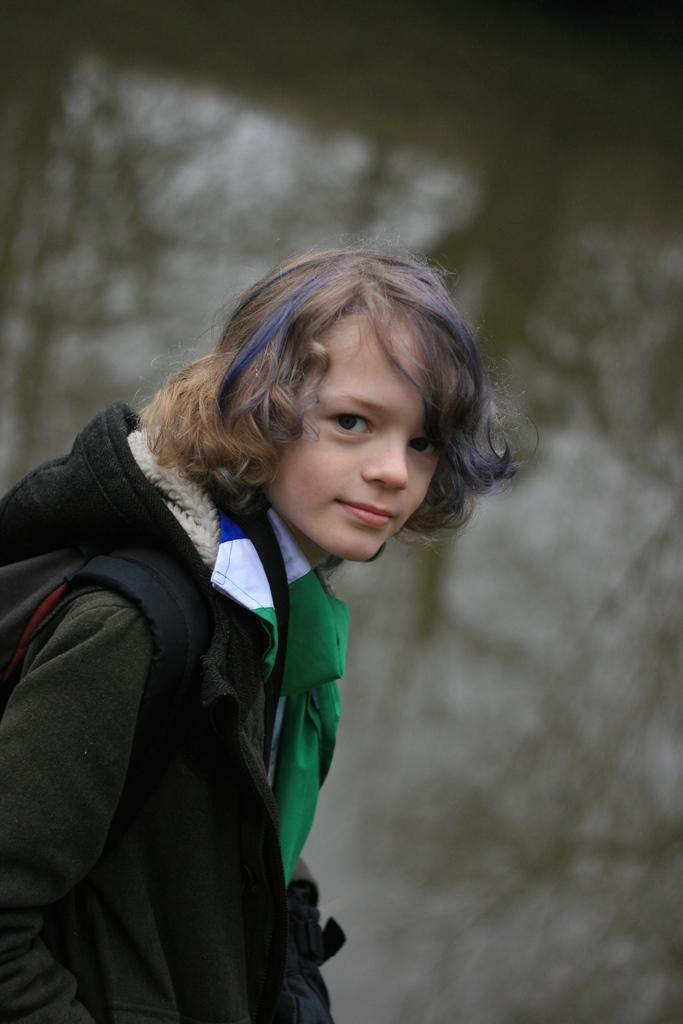Who or what is present in the image? There is a person in the image. What can be observed about the person's attire? The person is wearing clothes. Can you describe the person's posture or position? The person is standing. What type of harmony is being played by the horn in the image? There is no horn present in the image, so it is not possible to determine what type of harmony might be played. 